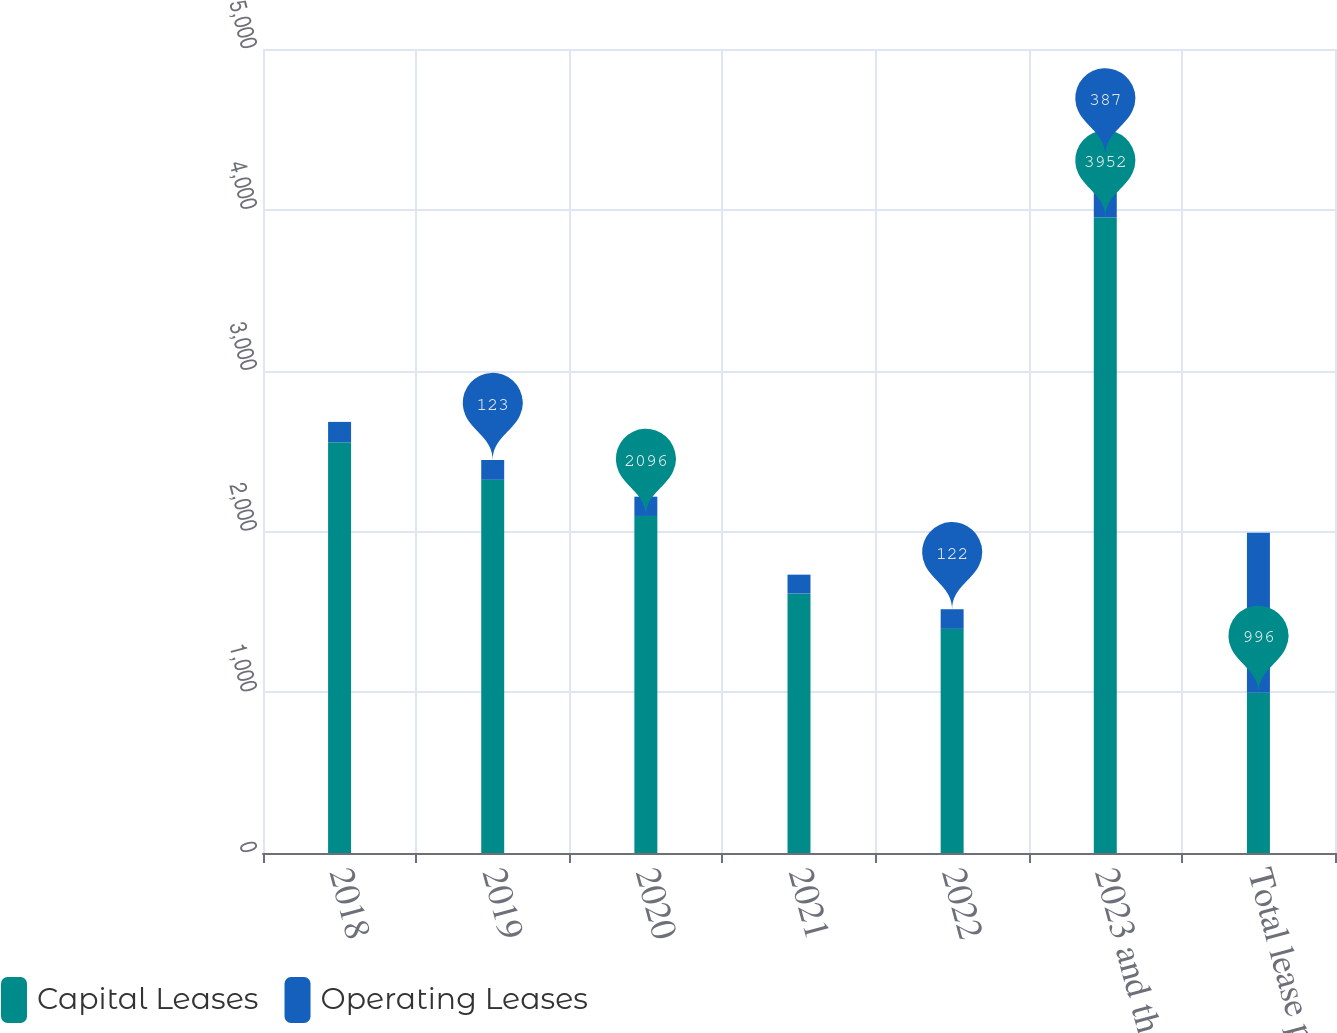Convert chart to OTSL. <chart><loc_0><loc_0><loc_500><loc_500><stacked_bar_chart><ecel><fcel>2018<fcel>2019<fcel>2020<fcel>2021<fcel>2022<fcel>2023 and thereafter<fcel>Total lease payments<nl><fcel>Capital Leases<fcel>2555<fcel>2321<fcel>2096<fcel>1613<fcel>1394<fcel>3952<fcel>996<nl><fcel>Operating Leases<fcel>126<fcel>123<fcel>120<fcel>118<fcel>122<fcel>387<fcel>996<nl></chart> 